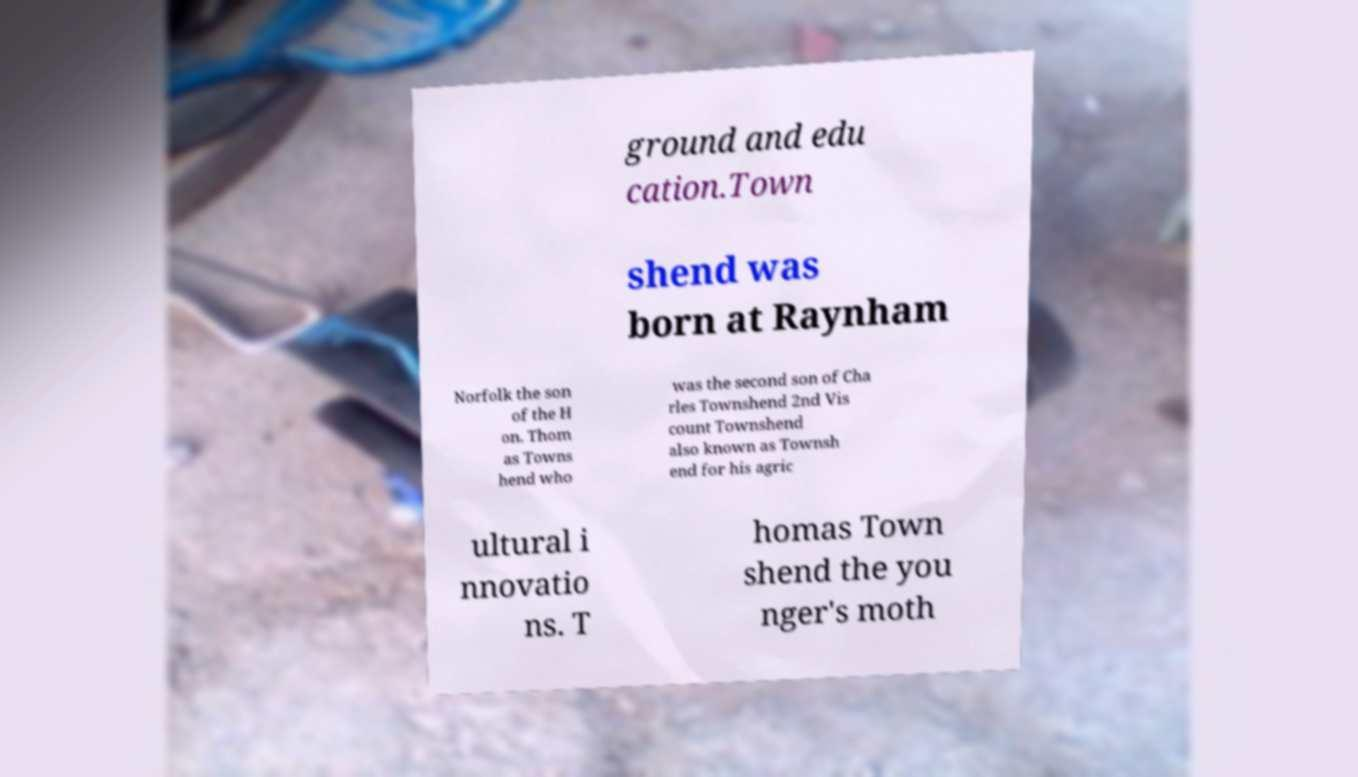Please identify and transcribe the text found in this image. ground and edu cation.Town shend was born at Raynham Norfolk the son of the H on. Thom as Towns hend who was the second son of Cha rles Townshend 2nd Vis count Townshend also known as Townsh end for his agric ultural i nnovatio ns. T homas Town shend the you nger's moth 